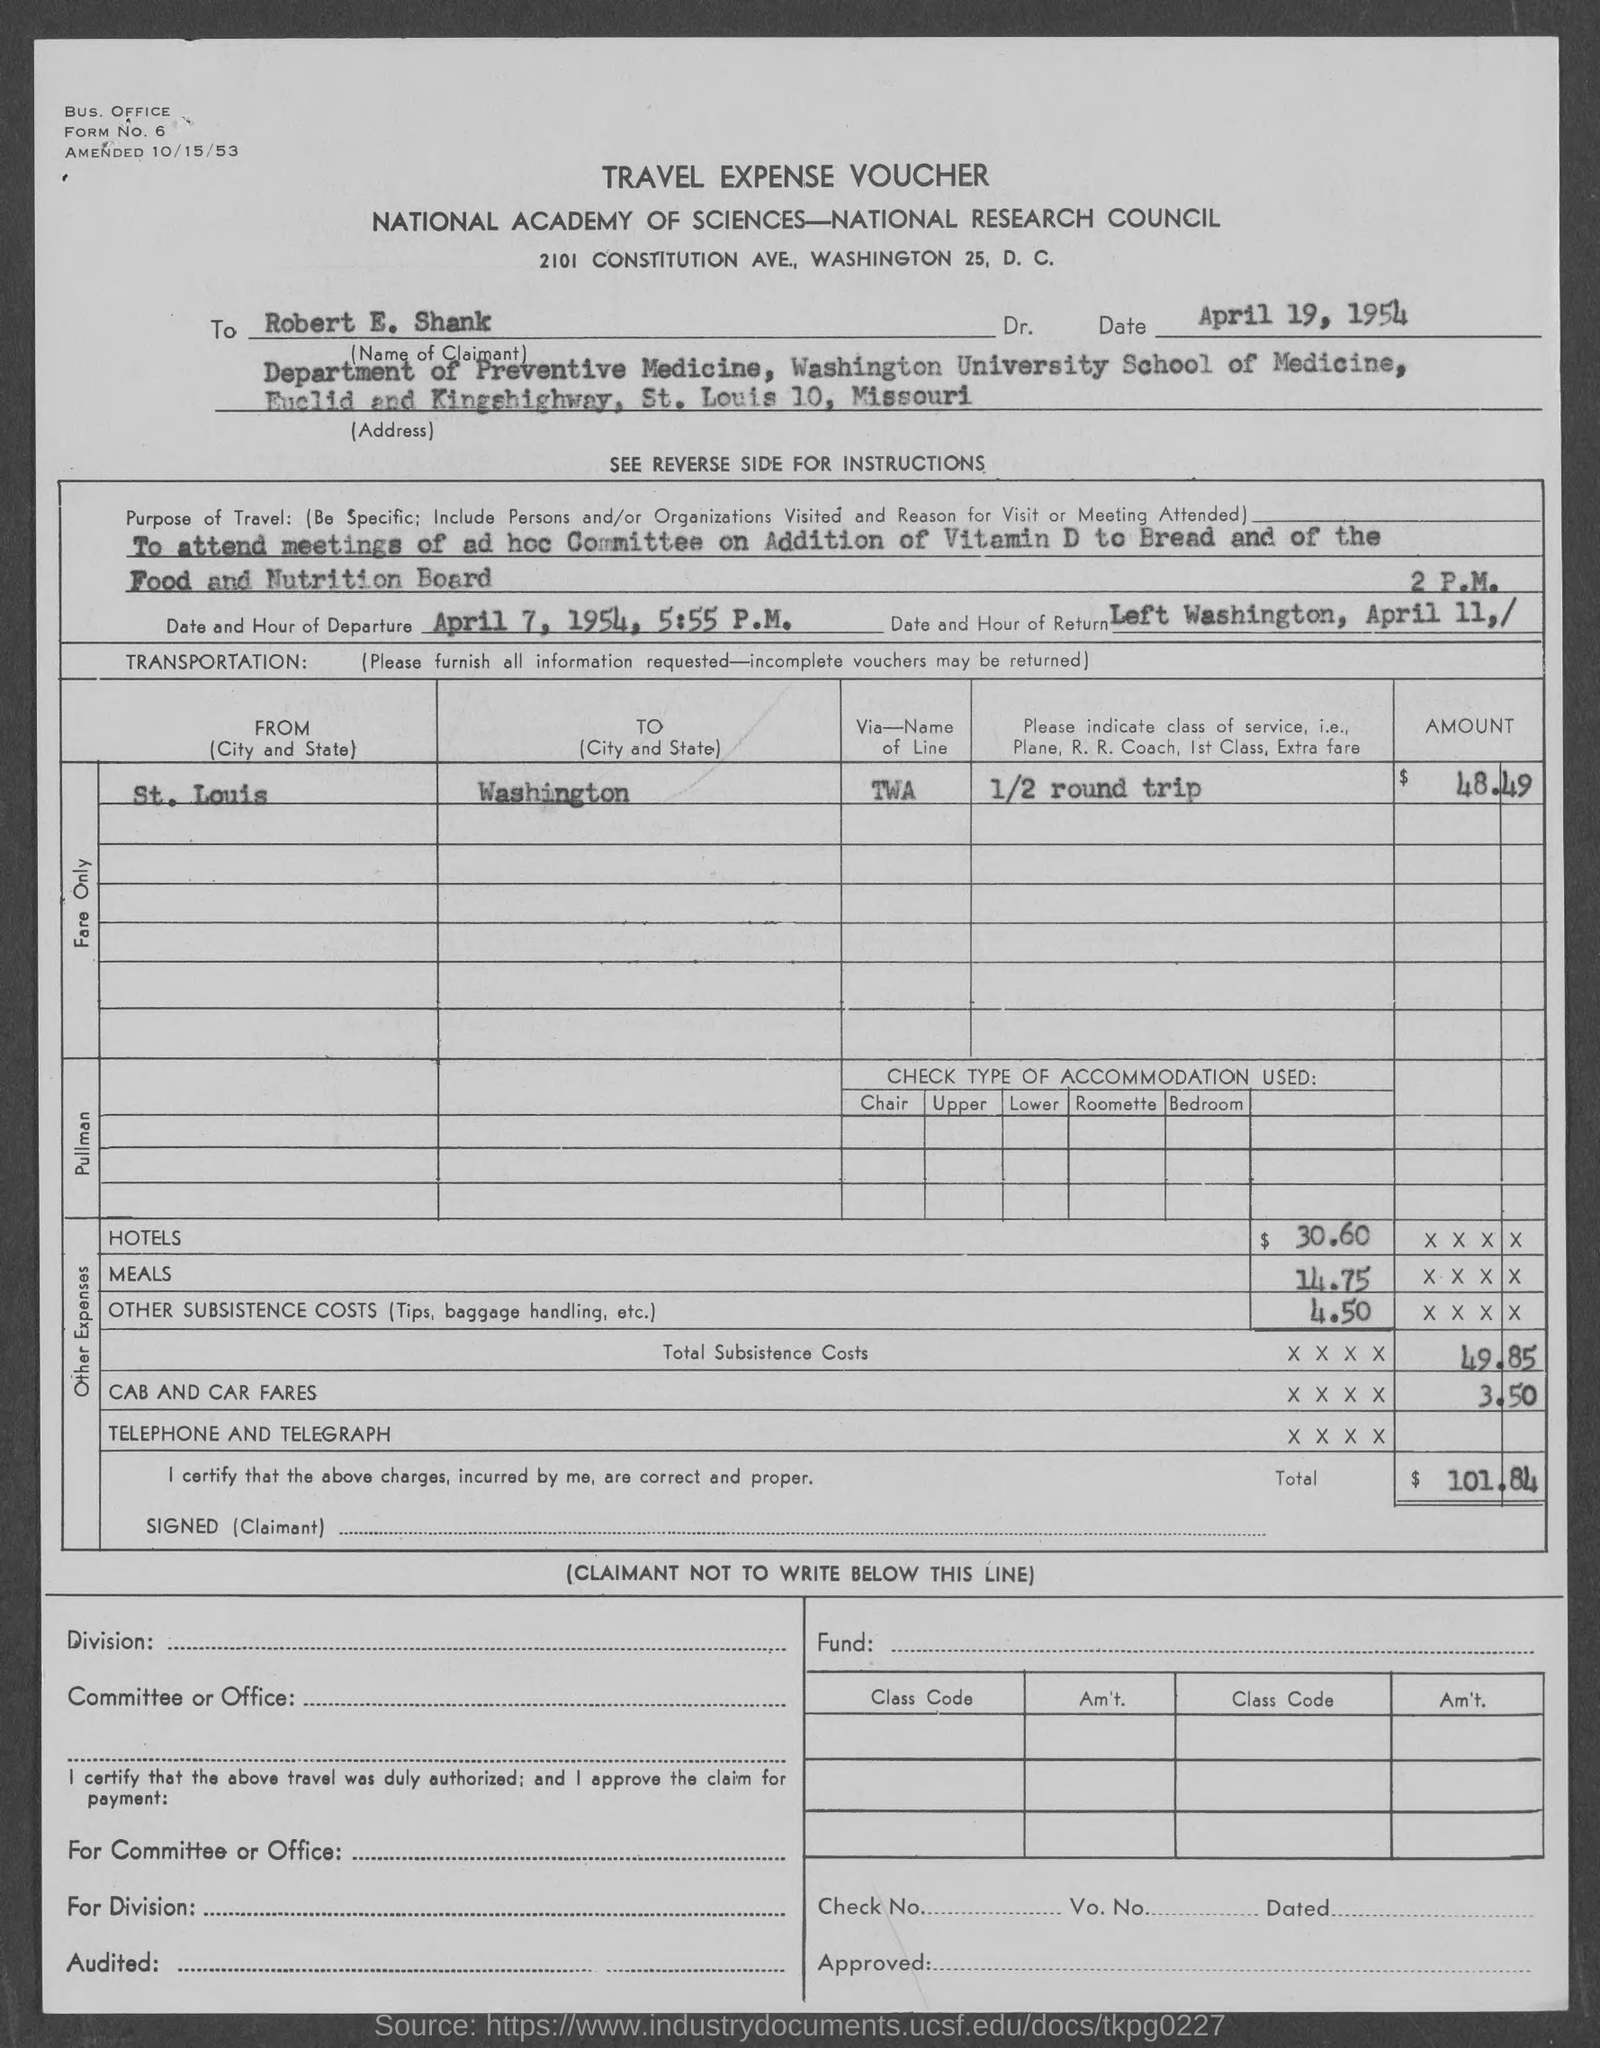Specify some key components in this picture. This voucher is for travel expenses. The travel was to Washington. 